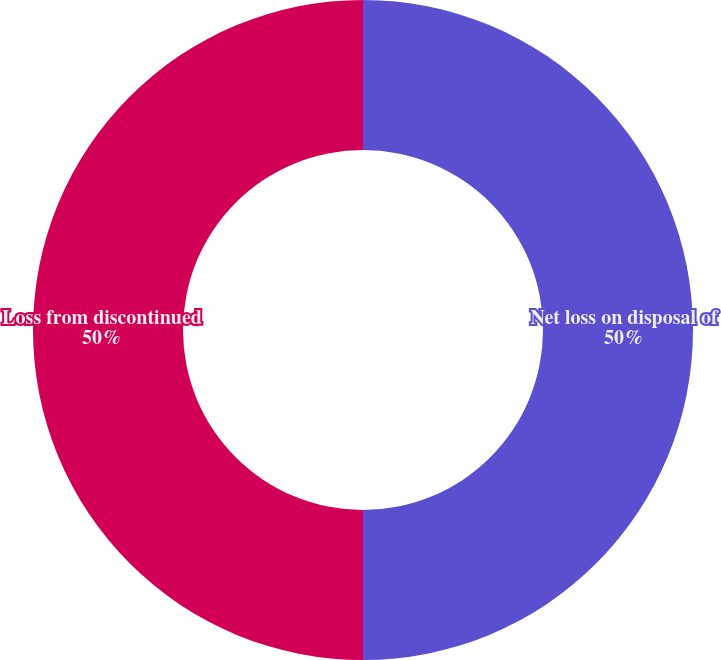<chart> <loc_0><loc_0><loc_500><loc_500><pie_chart><fcel>Net loss on disposal of<fcel>Loss from discontinued<nl><fcel>50.0%<fcel>50.0%<nl></chart> 